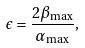Convert formula to latex. <formula><loc_0><loc_0><loc_500><loc_500>\epsilon = \frac { 2 \beta _ { \max } } { \alpha _ { \max } } ,</formula> 